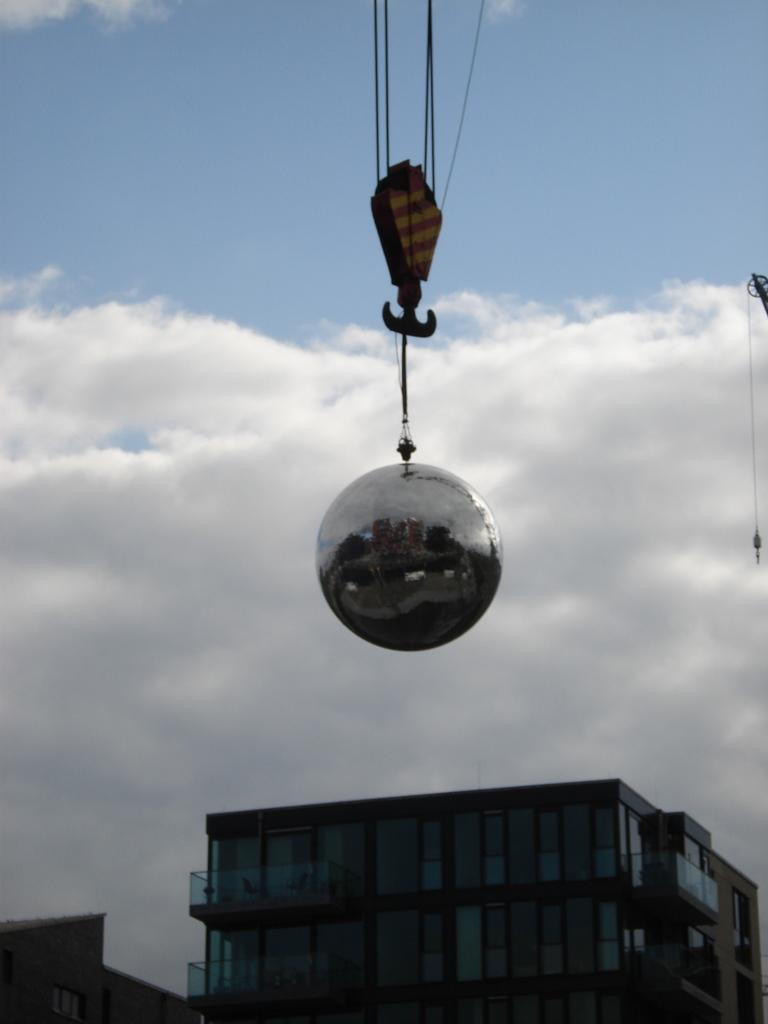What color is the ball in the image? The ball in the image is silver in color. How is the silver ball being supported in the image? The silver ball is held by a hanger. What type of structures can be seen at the bottom of the image? There are buildings at the bottom of the image. What can be seen in the background of the image? There are clouds in the background of the image. What is the color of the sky in the image? The sky is blue in the image. What type of oil is being used to lubricate the seat in the image? There is no seat or oil present in the image. 